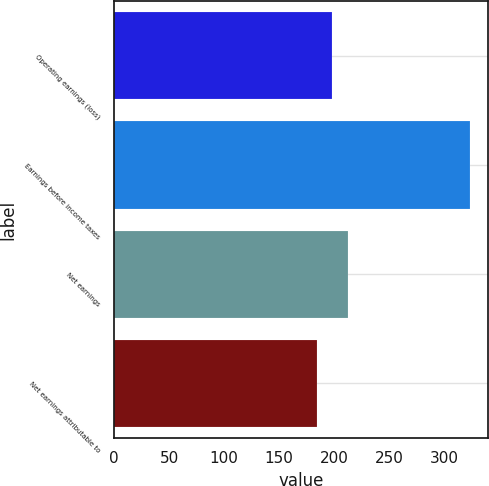Convert chart. <chart><loc_0><loc_0><loc_500><loc_500><bar_chart><fcel>Operating earnings (loss)<fcel>Earnings before income taxes<fcel>Net earnings<fcel>Net earnings attributable to<nl><fcel>198.46<fcel>324.1<fcel>212.42<fcel>184.5<nl></chart> 